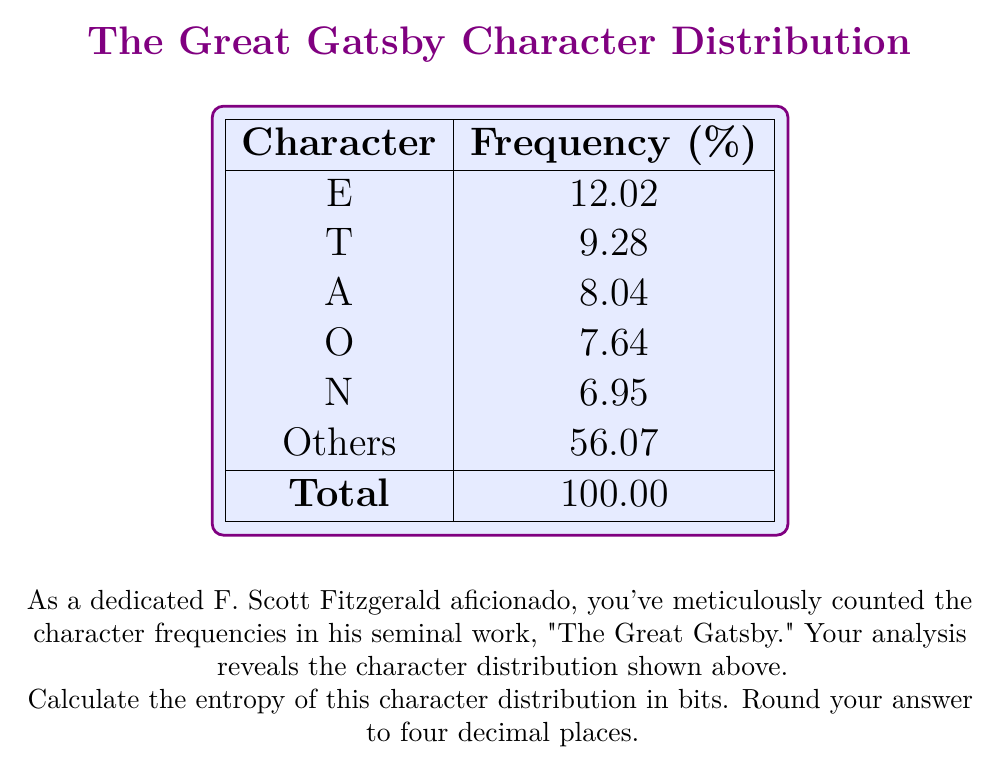What is the answer to this math problem? To calculate the entropy of the character distribution, we'll use the formula for Shannon entropy:

$$H = -\sum_{i=1}^n p_i \log_2(p_i)$$

Where $p_i$ is the probability of each character occurring.

Step 1: Convert percentages to probabilities
First, we need to convert the given percentages to probabilities by dividing by 100:
$p_E = 0.1202$
$p_T = 0.0928$
$p_A = 0.0804$
$p_O = 0.0764$
$p_N = 0.0695$
$p_{Others} = 0.5607$

Step 2: Calculate $-p_i \log_2(p_i)$ for each character
$-0.1202 \log_2(0.1202) = 0.3667$
$-0.0928 \log_2(0.0928) = 0.3178$
$-0.0804 \log_2(0.0804) = 0.2898$
$-0.0764 \log_2(0.0764) = 0.2808$
$-0.0695 \log_2(0.0695) = 0.2636$
$-0.5607 \log_2(0.5607) = 0.4731$

Step 3: Sum all the values
$H = 0.3667 + 0.3178 + 0.2898 + 0.2808 + 0.2636 + 0.4731 = 1.9918$ bits

Step 4: Round to four decimal places
$H \approx 1.9918$ bits

This entropy value indicates the average number of bits needed to encode each character in "The Great Gatsby" based on this frequency distribution.
Answer: 1.9918 bits 